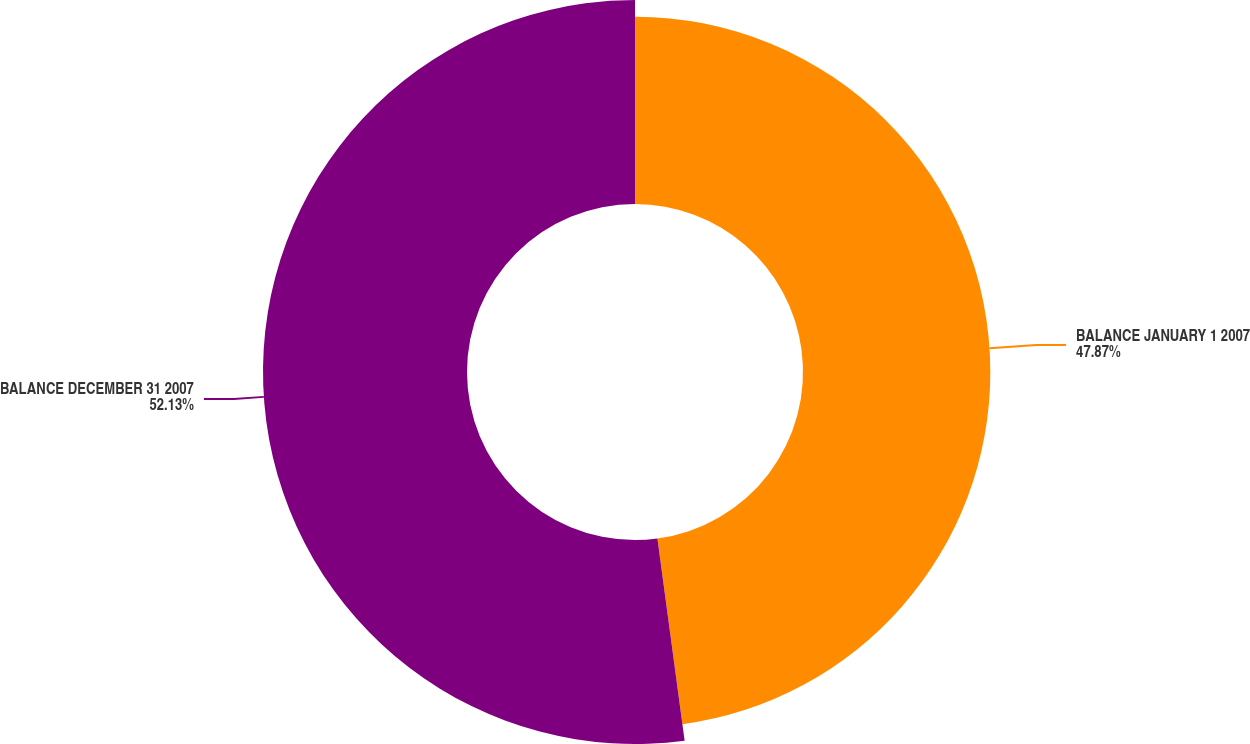Convert chart to OTSL. <chart><loc_0><loc_0><loc_500><loc_500><pie_chart><fcel>BALANCE JANUARY 1 2007<fcel>BALANCE DECEMBER 31 2007<nl><fcel>47.87%<fcel>52.13%<nl></chart> 